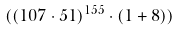<formula> <loc_0><loc_0><loc_500><loc_500>( ( 1 0 7 \cdot 5 1 ) ^ { 1 5 5 } \cdot ( 1 + 8 ) )</formula> 